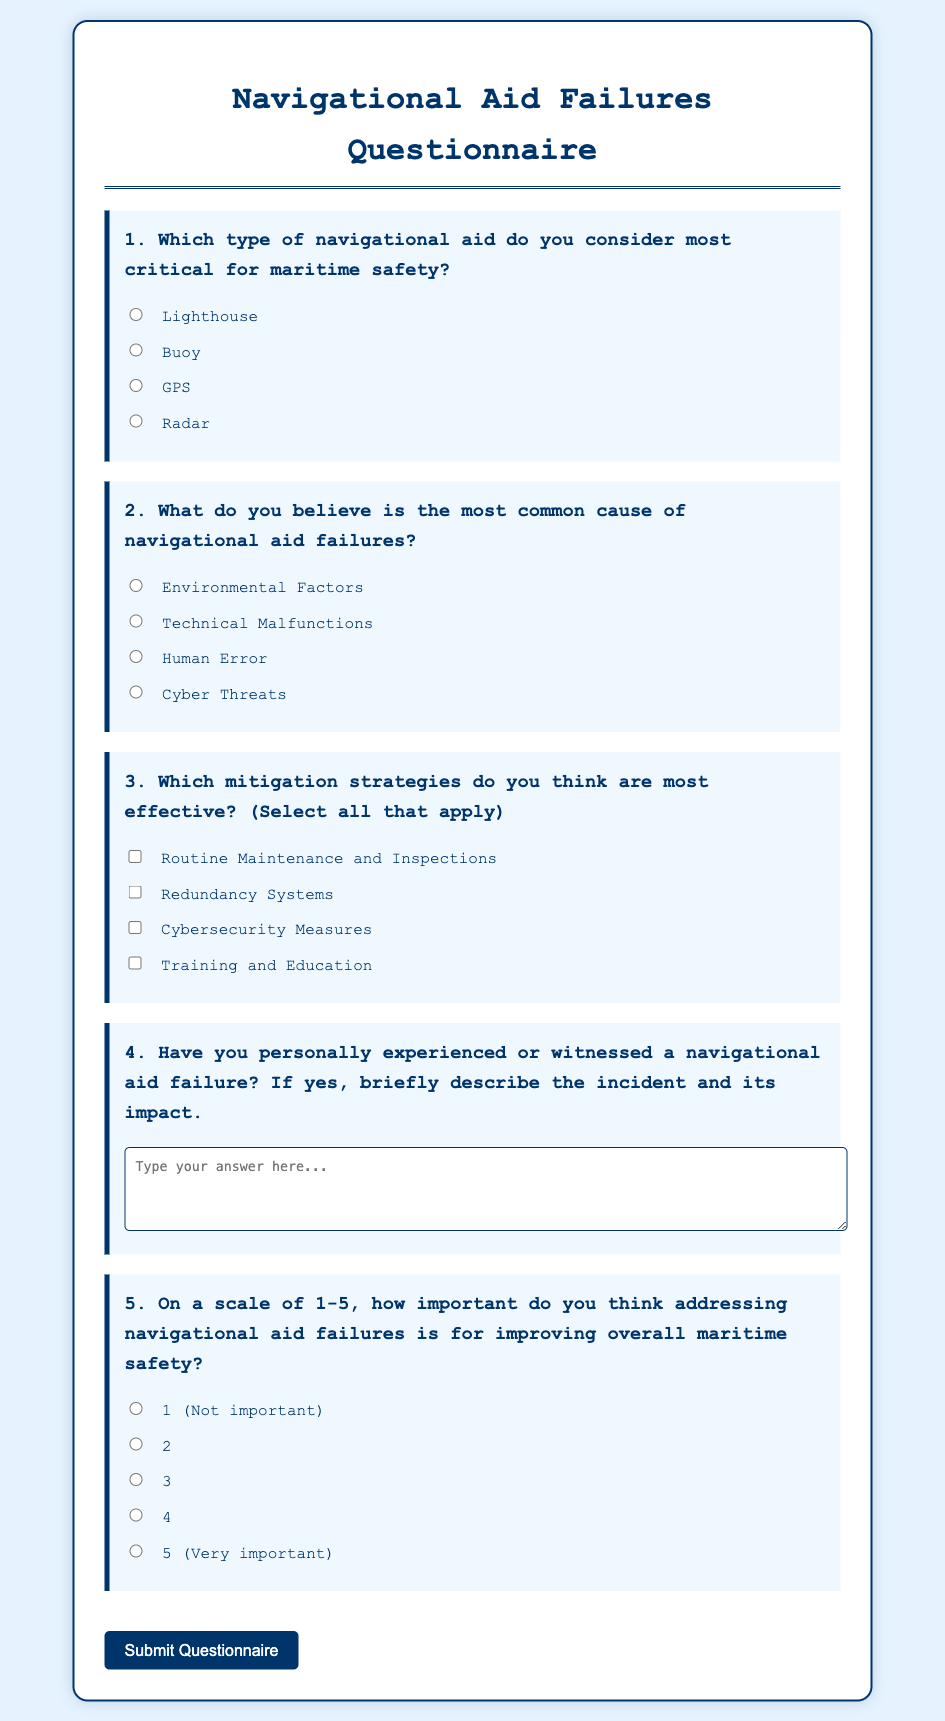What is the title of the document? The title is displayed prominently at the top of the document in the header section.
Answer: Navigational Aid Failures Questionnaire How many questions are included in the questionnaire? Each section in the form corresponds to a specific question, and there are five distinct questions presented.
Answer: 5 What type of navigational aid is considered most critical? The document lists multiple options for respondents to select from regarding critical navigational aids.
Answer: Lighthouse What is one common cause of navigational aid failures mentioned? The document specifies various reasons and prompts the respondent to select one as the most common cause.
Answer: Technical Malfunctions Which mitigation strategy is associated with improving navigational aid reliability? The document includes options for respondents to select mitigation strategies, with routine maintenance being one of them.
Answer: Routine Maintenance and Inspections What is the purpose of Question 4 in the questionnaire? This question invites participants to share personal experiences regarding navigational aid failures along with their impacts.
Answer: To describe an incident and its impact On a scale of 1-5, how is the importance of addressing navigational aid failures characterized? The document provides a scale for respondents to assess the significance of addressing navigational aid failures for safety improvements.
Answer: 1-5 What button is provided for submitting the questionnaire? The form includes a button at the end for participants to complete their responses.
Answer: Submit Questionnaire 